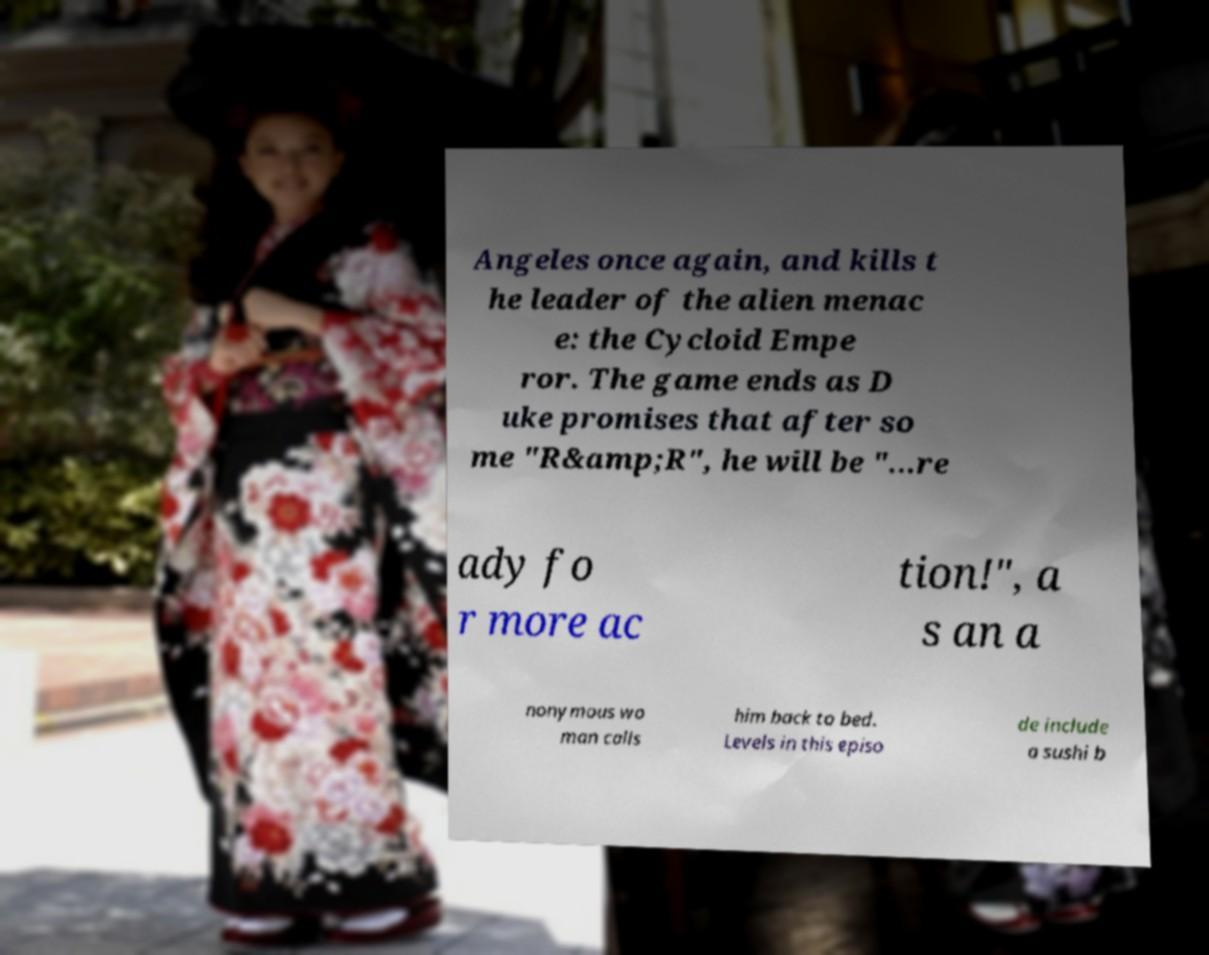I need the written content from this picture converted into text. Can you do that? Angeles once again, and kills t he leader of the alien menac e: the Cycloid Empe ror. The game ends as D uke promises that after so me "R&amp;R", he will be "...re ady fo r more ac tion!", a s an a nonymous wo man calls him back to bed. Levels in this episo de include a sushi b 